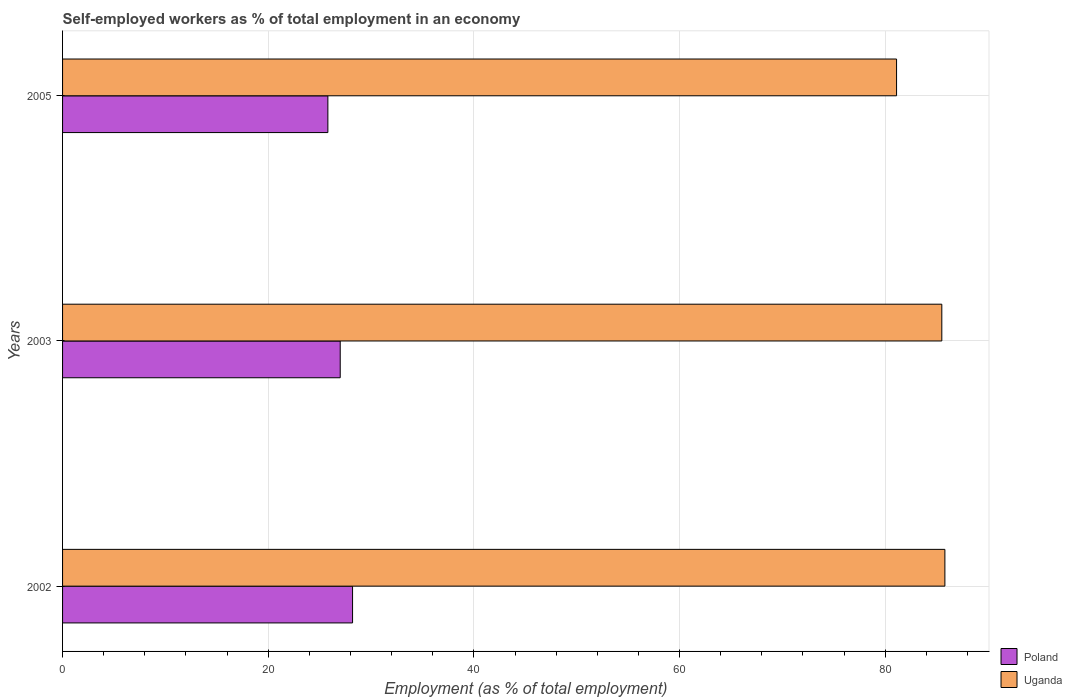How many groups of bars are there?
Provide a succinct answer. 3. Are the number of bars on each tick of the Y-axis equal?
Provide a short and direct response. Yes. How many bars are there on the 1st tick from the top?
Give a very brief answer. 2. What is the percentage of self-employed workers in Poland in 2002?
Your answer should be very brief. 28.2. Across all years, what is the maximum percentage of self-employed workers in Uganda?
Provide a succinct answer. 85.8. Across all years, what is the minimum percentage of self-employed workers in Uganda?
Your answer should be very brief. 81.1. What is the total percentage of self-employed workers in Poland in the graph?
Your response must be concise. 81. What is the difference between the percentage of self-employed workers in Poland in 2002 and that in 2003?
Your response must be concise. 1.2. What is the difference between the percentage of self-employed workers in Uganda in 2005 and the percentage of self-employed workers in Poland in 2002?
Provide a succinct answer. 52.9. What is the average percentage of self-employed workers in Uganda per year?
Provide a succinct answer. 84.13. In the year 2003, what is the difference between the percentage of self-employed workers in Poland and percentage of self-employed workers in Uganda?
Keep it short and to the point. -58.5. What is the ratio of the percentage of self-employed workers in Poland in 2002 to that in 2005?
Your answer should be compact. 1.09. What is the difference between the highest and the second highest percentage of self-employed workers in Poland?
Make the answer very short. 1.2. What is the difference between the highest and the lowest percentage of self-employed workers in Uganda?
Ensure brevity in your answer.  4.7. In how many years, is the percentage of self-employed workers in Poland greater than the average percentage of self-employed workers in Poland taken over all years?
Ensure brevity in your answer.  1. What does the 2nd bar from the top in 2003 represents?
Provide a short and direct response. Poland. What does the 1st bar from the bottom in 2003 represents?
Keep it short and to the point. Poland. How many bars are there?
Ensure brevity in your answer.  6. How many years are there in the graph?
Provide a short and direct response. 3. Are the values on the major ticks of X-axis written in scientific E-notation?
Your answer should be very brief. No. Where does the legend appear in the graph?
Offer a very short reply. Bottom right. How many legend labels are there?
Offer a very short reply. 2. What is the title of the graph?
Your response must be concise. Self-employed workers as % of total employment in an economy. Does "Korea (Republic)" appear as one of the legend labels in the graph?
Your response must be concise. No. What is the label or title of the X-axis?
Provide a succinct answer. Employment (as % of total employment). What is the Employment (as % of total employment) of Poland in 2002?
Your answer should be very brief. 28.2. What is the Employment (as % of total employment) of Uganda in 2002?
Provide a short and direct response. 85.8. What is the Employment (as % of total employment) in Poland in 2003?
Offer a terse response. 27. What is the Employment (as % of total employment) of Uganda in 2003?
Your answer should be compact. 85.5. What is the Employment (as % of total employment) in Poland in 2005?
Your response must be concise. 25.8. What is the Employment (as % of total employment) of Uganda in 2005?
Keep it short and to the point. 81.1. Across all years, what is the maximum Employment (as % of total employment) in Poland?
Ensure brevity in your answer.  28.2. Across all years, what is the maximum Employment (as % of total employment) in Uganda?
Your answer should be very brief. 85.8. Across all years, what is the minimum Employment (as % of total employment) in Poland?
Provide a short and direct response. 25.8. Across all years, what is the minimum Employment (as % of total employment) in Uganda?
Provide a short and direct response. 81.1. What is the total Employment (as % of total employment) in Poland in the graph?
Make the answer very short. 81. What is the total Employment (as % of total employment) in Uganda in the graph?
Your answer should be very brief. 252.4. What is the difference between the Employment (as % of total employment) of Poland in 2002 and that in 2003?
Offer a very short reply. 1.2. What is the difference between the Employment (as % of total employment) of Uganda in 2002 and that in 2005?
Offer a terse response. 4.7. What is the difference between the Employment (as % of total employment) in Poland in 2003 and that in 2005?
Provide a succinct answer. 1.2. What is the difference between the Employment (as % of total employment) of Poland in 2002 and the Employment (as % of total employment) of Uganda in 2003?
Keep it short and to the point. -57.3. What is the difference between the Employment (as % of total employment) in Poland in 2002 and the Employment (as % of total employment) in Uganda in 2005?
Give a very brief answer. -52.9. What is the difference between the Employment (as % of total employment) in Poland in 2003 and the Employment (as % of total employment) in Uganda in 2005?
Your answer should be compact. -54.1. What is the average Employment (as % of total employment) of Uganda per year?
Your answer should be very brief. 84.13. In the year 2002, what is the difference between the Employment (as % of total employment) in Poland and Employment (as % of total employment) in Uganda?
Make the answer very short. -57.6. In the year 2003, what is the difference between the Employment (as % of total employment) in Poland and Employment (as % of total employment) in Uganda?
Your answer should be very brief. -58.5. In the year 2005, what is the difference between the Employment (as % of total employment) in Poland and Employment (as % of total employment) in Uganda?
Give a very brief answer. -55.3. What is the ratio of the Employment (as % of total employment) of Poland in 2002 to that in 2003?
Offer a terse response. 1.04. What is the ratio of the Employment (as % of total employment) of Uganda in 2002 to that in 2003?
Ensure brevity in your answer.  1. What is the ratio of the Employment (as % of total employment) of Poland in 2002 to that in 2005?
Give a very brief answer. 1.09. What is the ratio of the Employment (as % of total employment) in Uganda in 2002 to that in 2005?
Ensure brevity in your answer.  1.06. What is the ratio of the Employment (as % of total employment) of Poland in 2003 to that in 2005?
Your response must be concise. 1.05. What is the ratio of the Employment (as % of total employment) in Uganda in 2003 to that in 2005?
Offer a very short reply. 1.05. What is the difference between the highest and the second highest Employment (as % of total employment) in Uganda?
Provide a short and direct response. 0.3. What is the difference between the highest and the lowest Employment (as % of total employment) of Poland?
Give a very brief answer. 2.4. What is the difference between the highest and the lowest Employment (as % of total employment) in Uganda?
Make the answer very short. 4.7. 